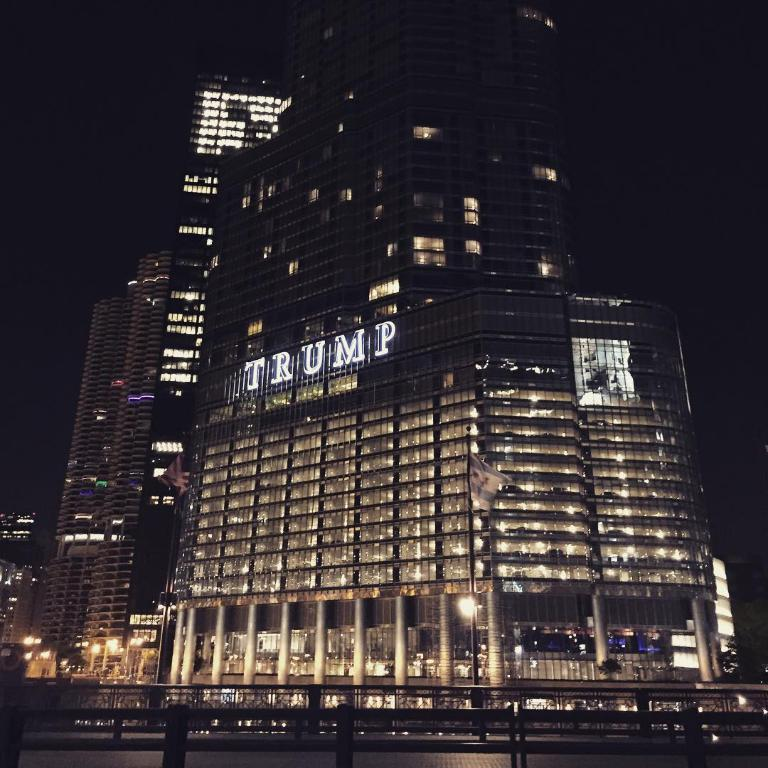<image>
Present a compact description of the photo's key features. A well lit building with a Trump sign at the top. 